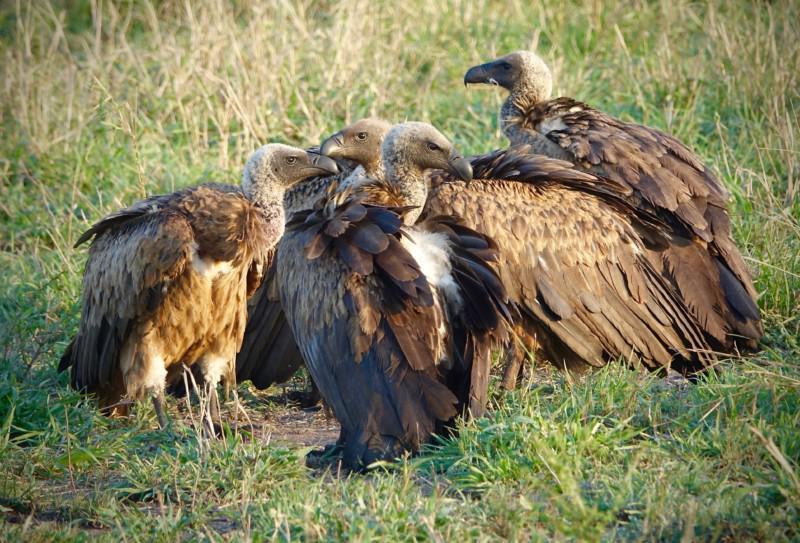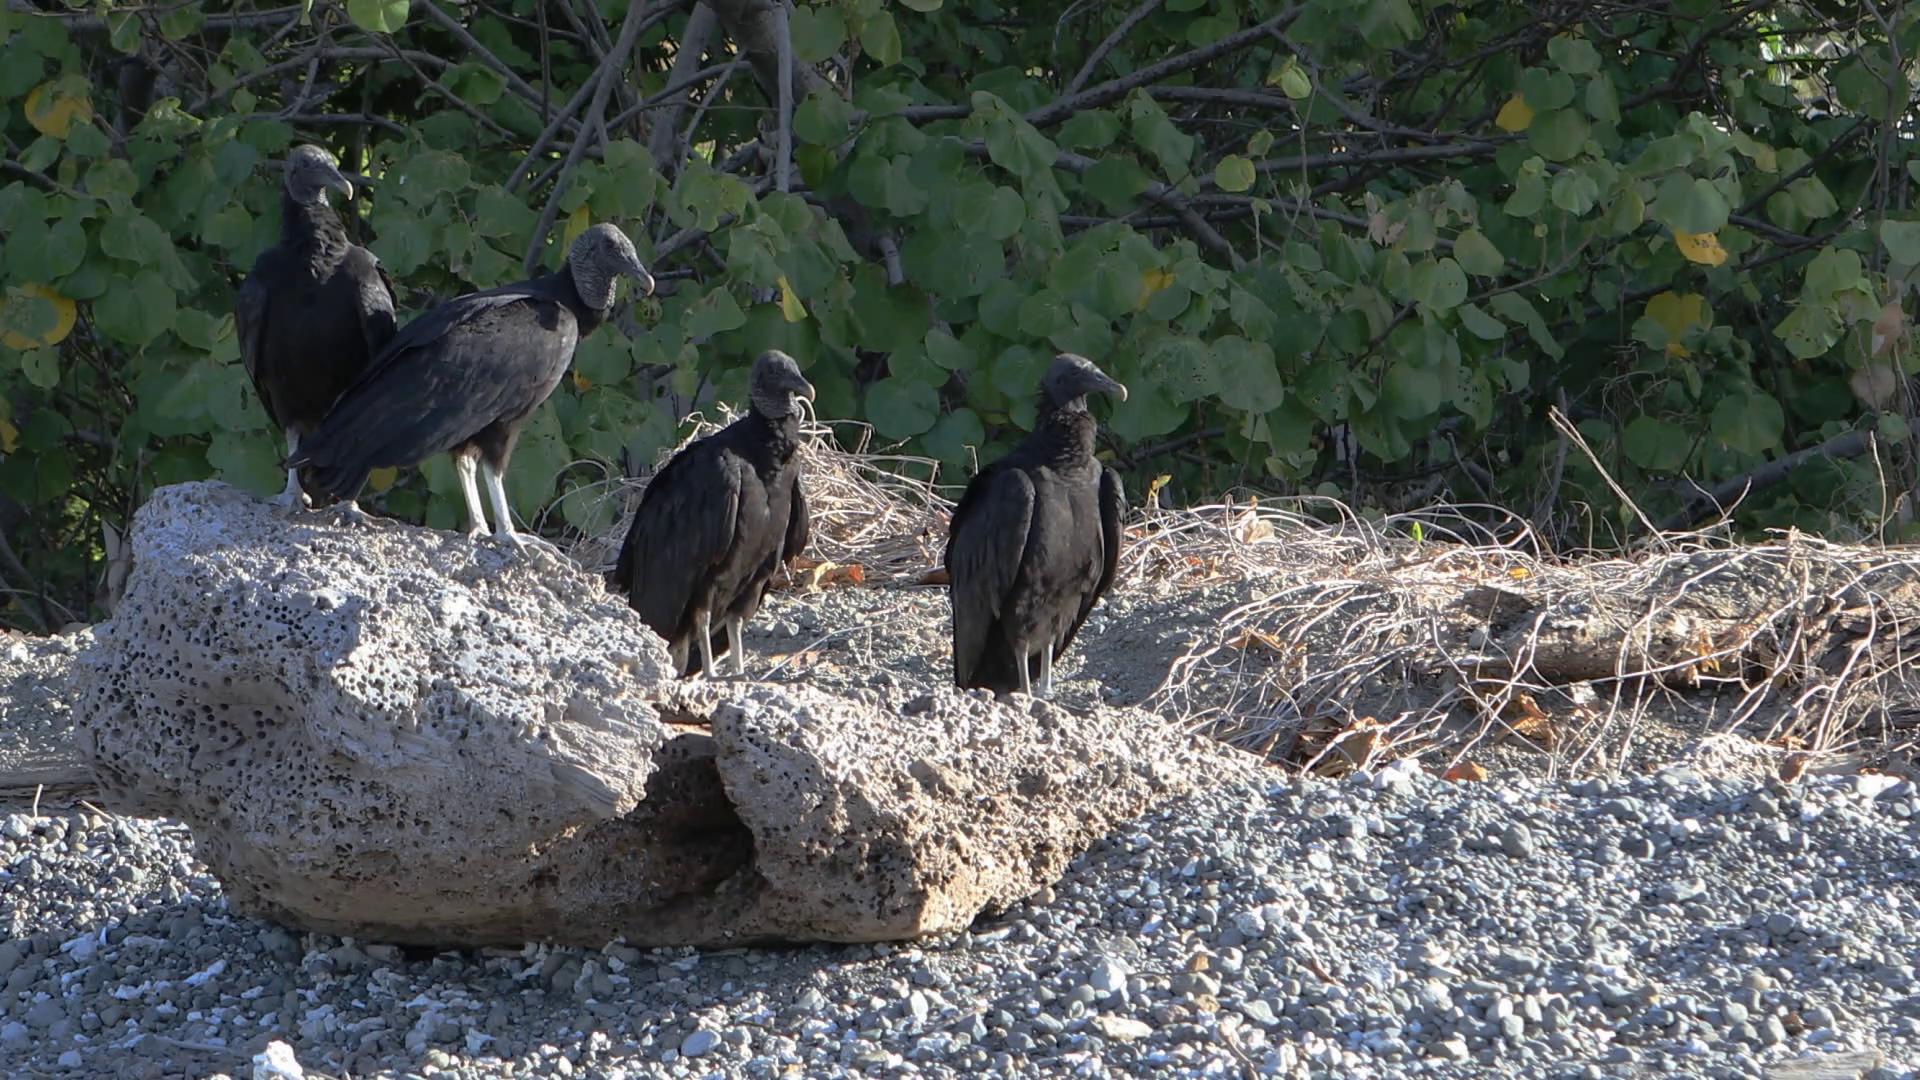The first image is the image on the left, the second image is the image on the right. Considering the images on both sides, is "In at least one image there is a total of five vultures." valid? Answer yes or no. Yes. The first image is the image on the left, the second image is the image on the right. Examine the images to the left and right. Is the description "An image shows two vultures in the foreground, at least one with its wings outspread." accurate? Answer yes or no. No. 